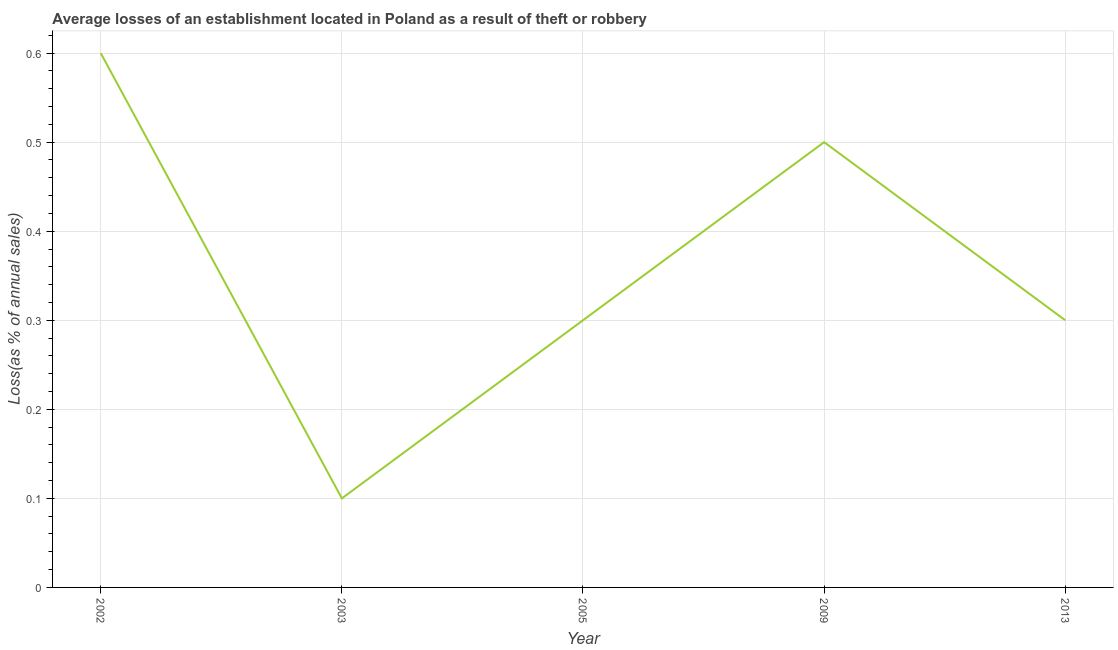What is the losses due to theft in 2002?
Offer a very short reply. 0.6. In which year was the losses due to theft minimum?
Offer a very short reply. 2003. What is the difference between the losses due to theft in 2002 and 2009?
Give a very brief answer. 0.1. What is the average losses due to theft per year?
Make the answer very short. 0.36. What is the median losses due to theft?
Give a very brief answer. 0.3. In how many years, is the losses due to theft greater than 0.12000000000000001 %?
Your response must be concise. 4. What is the ratio of the losses due to theft in 2005 to that in 2013?
Provide a short and direct response. 1. Is the losses due to theft in 2003 less than that in 2013?
Offer a very short reply. Yes. Is the difference between the losses due to theft in 2003 and 2005 greater than the difference between any two years?
Provide a succinct answer. No. What is the difference between the highest and the second highest losses due to theft?
Give a very brief answer. 0.1. What is the difference between the highest and the lowest losses due to theft?
Offer a terse response. 0.5. In how many years, is the losses due to theft greater than the average losses due to theft taken over all years?
Ensure brevity in your answer.  2. How many lines are there?
Provide a succinct answer. 1. How many years are there in the graph?
Your answer should be compact. 5. Does the graph contain any zero values?
Offer a terse response. No. What is the title of the graph?
Offer a very short reply. Average losses of an establishment located in Poland as a result of theft or robbery. What is the label or title of the X-axis?
Give a very brief answer. Year. What is the label or title of the Y-axis?
Your answer should be compact. Loss(as % of annual sales). What is the Loss(as % of annual sales) of 2003?
Provide a succinct answer. 0.1. What is the Loss(as % of annual sales) of 2005?
Provide a succinct answer. 0.3. What is the difference between the Loss(as % of annual sales) in 2002 and 2013?
Ensure brevity in your answer.  0.3. What is the difference between the Loss(as % of annual sales) in 2003 and 2005?
Provide a short and direct response. -0.2. What is the difference between the Loss(as % of annual sales) in 2003 and 2009?
Ensure brevity in your answer.  -0.4. What is the ratio of the Loss(as % of annual sales) in 2002 to that in 2005?
Your answer should be very brief. 2. What is the ratio of the Loss(as % of annual sales) in 2002 to that in 2013?
Make the answer very short. 2. What is the ratio of the Loss(as % of annual sales) in 2003 to that in 2005?
Offer a very short reply. 0.33. What is the ratio of the Loss(as % of annual sales) in 2003 to that in 2009?
Offer a terse response. 0.2. What is the ratio of the Loss(as % of annual sales) in 2003 to that in 2013?
Offer a very short reply. 0.33. What is the ratio of the Loss(as % of annual sales) in 2005 to that in 2009?
Give a very brief answer. 0.6. What is the ratio of the Loss(as % of annual sales) in 2009 to that in 2013?
Make the answer very short. 1.67. 